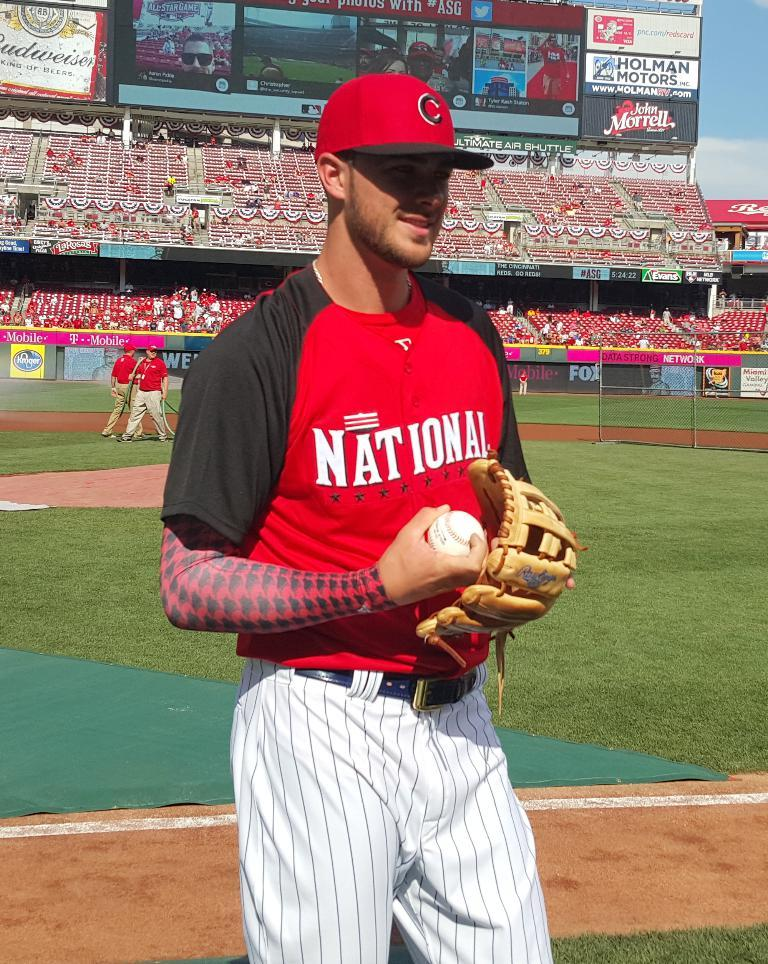<image>
Provide a brief description of the given image. A player stands on the field wearing a National jersey in a stadium. 